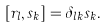<formula> <loc_0><loc_0><loc_500><loc_500>[ r _ { l } , s _ { k } ] = \delta _ { l k } s _ { k } .</formula> 